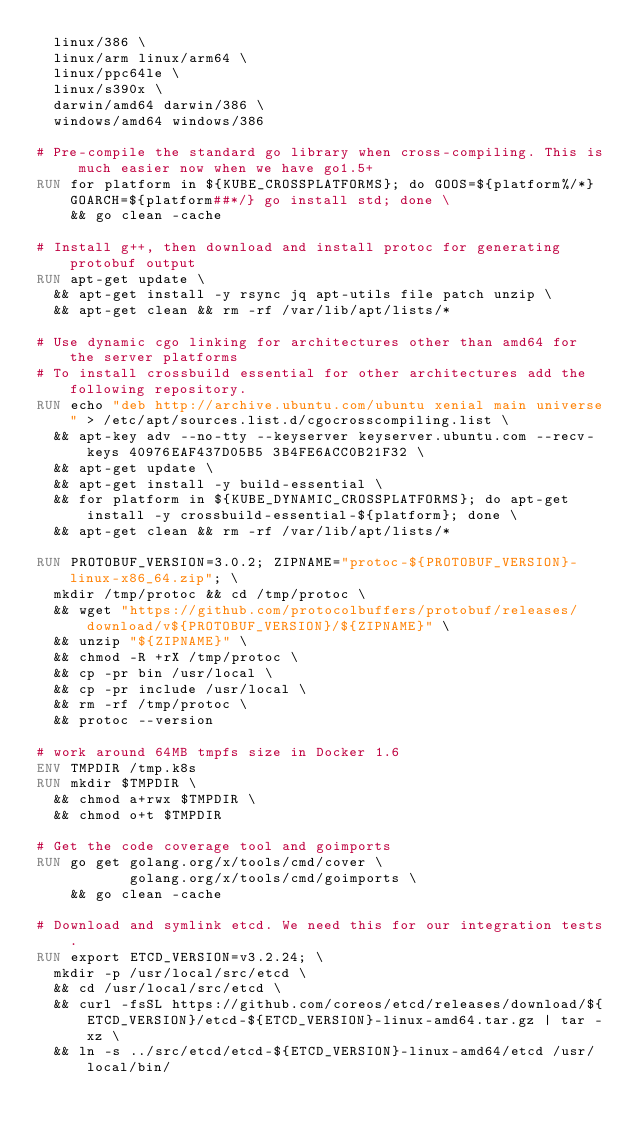Convert code to text. <code><loc_0><loc_0><loc_500><loc_500><_Dockerfile_>  linux/386 \
  linux/arm linux/arm64 \
  linux/ppc64le \
  linux/s390x \
  darwin/amd64 darwin/386 \
  windows/amd64 windows/386

# Pre-compile the standard go library when cross-compiling. This is much easier now when we have go1.5+
RUN for platform in ${KUBE_CROSSPLATFORMS}; do GOOS=${platform%/*} GOARCH=${platform##*/} go install std; done \
    && go clean -cache

# Install g++, then download and install protoc for generating protobuf output
RUN apt-get update \
  && apt-get install -y rsync jq apt-utils file patch unzip \
  && apt-get clean && rm -rf /var/lib/apt/lists/*

# Use dynamic cgo linking for architectures other than amd64 for the server platforms
# To install crossbuild essential for other architectures add the following repository.
RUN echo "deb http://archive.ubuntu.com/ubuntu xenial main universe" > /etc/apt/sources.list.d/cgocrosscompiling.list \
  && apt-key adv --no-tty --keyserver keyserver.ubuntu.com --recv-keys 40976EAF437D05B5 3B4FE6ACC0B21F32 \
  && apt-get update \
  && apt-get install -y build-essential \
  && for platform in ${KUBE_DYNAMIC_CROSSPLATFORMS}; do apt-get install -y crossbuild-essential-${platform}; done \
  && apt-get clean && rm -rf /var/lib/apt/lists/*

RUN PROTOBUF_VERSION=3.0.2; ZIPNAME="protoc-${PROTOBUF_VERSION}-linux-x86_64.zip"; \
  mkdir /tmp/protoc && cd /tmp/protoc \
  && wget "https://github.com/protocolbuffers/protobuf/releases/download/v${PROTOBUF_VERSION}/${ZIPNAME}" \
  && unzip "${ZIPNAME}" \
  && chmod -R +rX /tmp/protoc \
  && cp -pr bin /usr/local \
  && cp -pr include /usr/local \
  && rm -rf /tmp/protoc \
  && protoc --version

# work around 64MB tmpfs size in Docker 1.6
ENV TMPDIR /tmp.k8s
RUN mkdir $TMPDIR \
  && chmod a+rwx $TMPDIR \
  && chmod o+t $TMPDIR

# Get the code coverage tool and goimports
RUN go get golang.org/x/tools/cmd/cover \
           golang.org/x/tools/cmd/goimports \
    && go clean -cache

# Download and symlink etcd. We need this for our integration tests.
RUN export ETCD_VERSION=v3.2.24; \
  mkdir -p /usr/local/src/etcd \
  && cd /usr/local/src/etcd \
  && curl -fsSL https://github.com/coreos/etcd/releases/download/${ETCD_VERSION}/etcd-${ETCD_VERSION}-linux-amd64.tar.gz | tar -xz \
  && ln -s ../src/etcd/etcd-${ETCD_VERSION}-linux-amd64/etcd /usr/local/bin/
</code> 